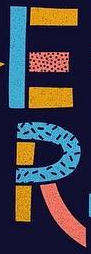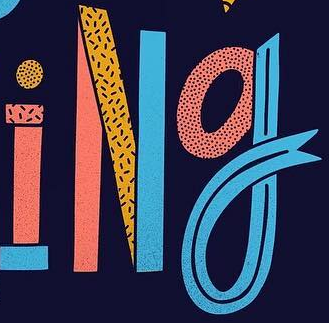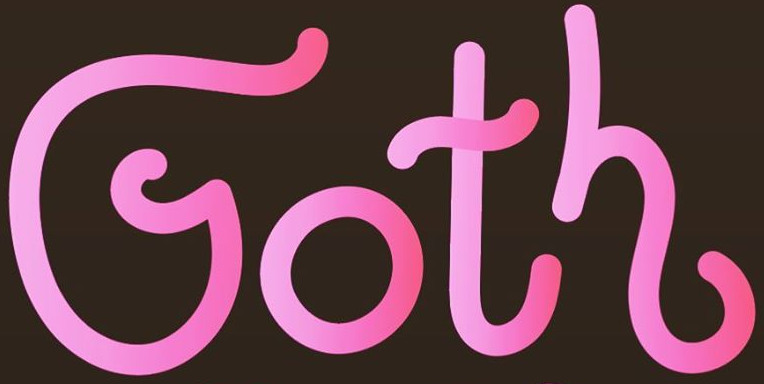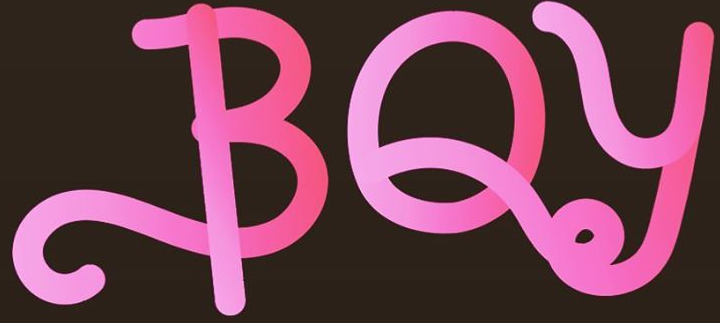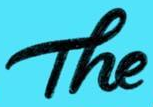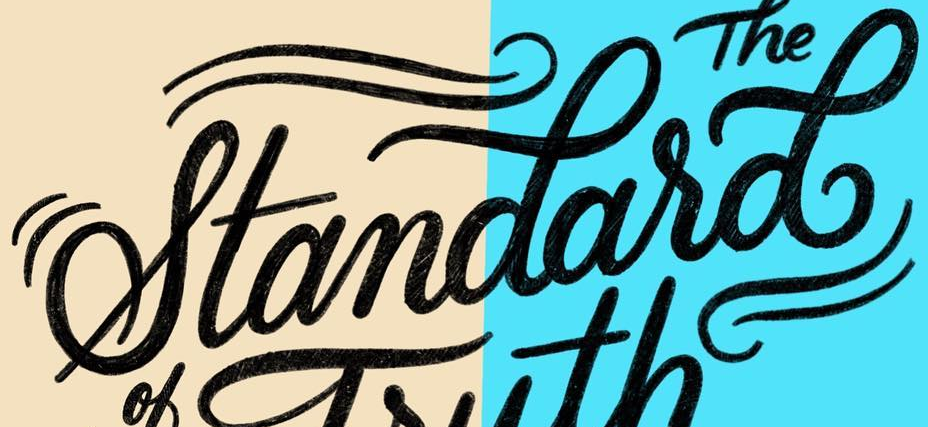What words can you see in these images in sequence, separated by a semicolon? ER; iNg; Goth; BOy; The; standasd 